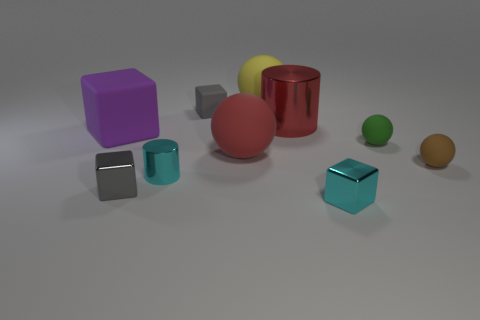Subtract all yellow balls. How many balls are left? 3 Subtract all small blocks. How many blocks are left? 1 Subtract all green blocks. Subtract all cyan cylinders. How many blocks are left? 4 Subtract all cylinders. How many objects are left? 8 Add 4 tiny blue cylinders. How many tiny blue cylinders exist? 4 Subtract 1 red spheres. How many objects are left? 9 Subtract all tiny metal blocks. Subtract all tiny green blocks. How many objects are left? 8 Add 5 green rubber balls. How many green rubber balls are left? 6 